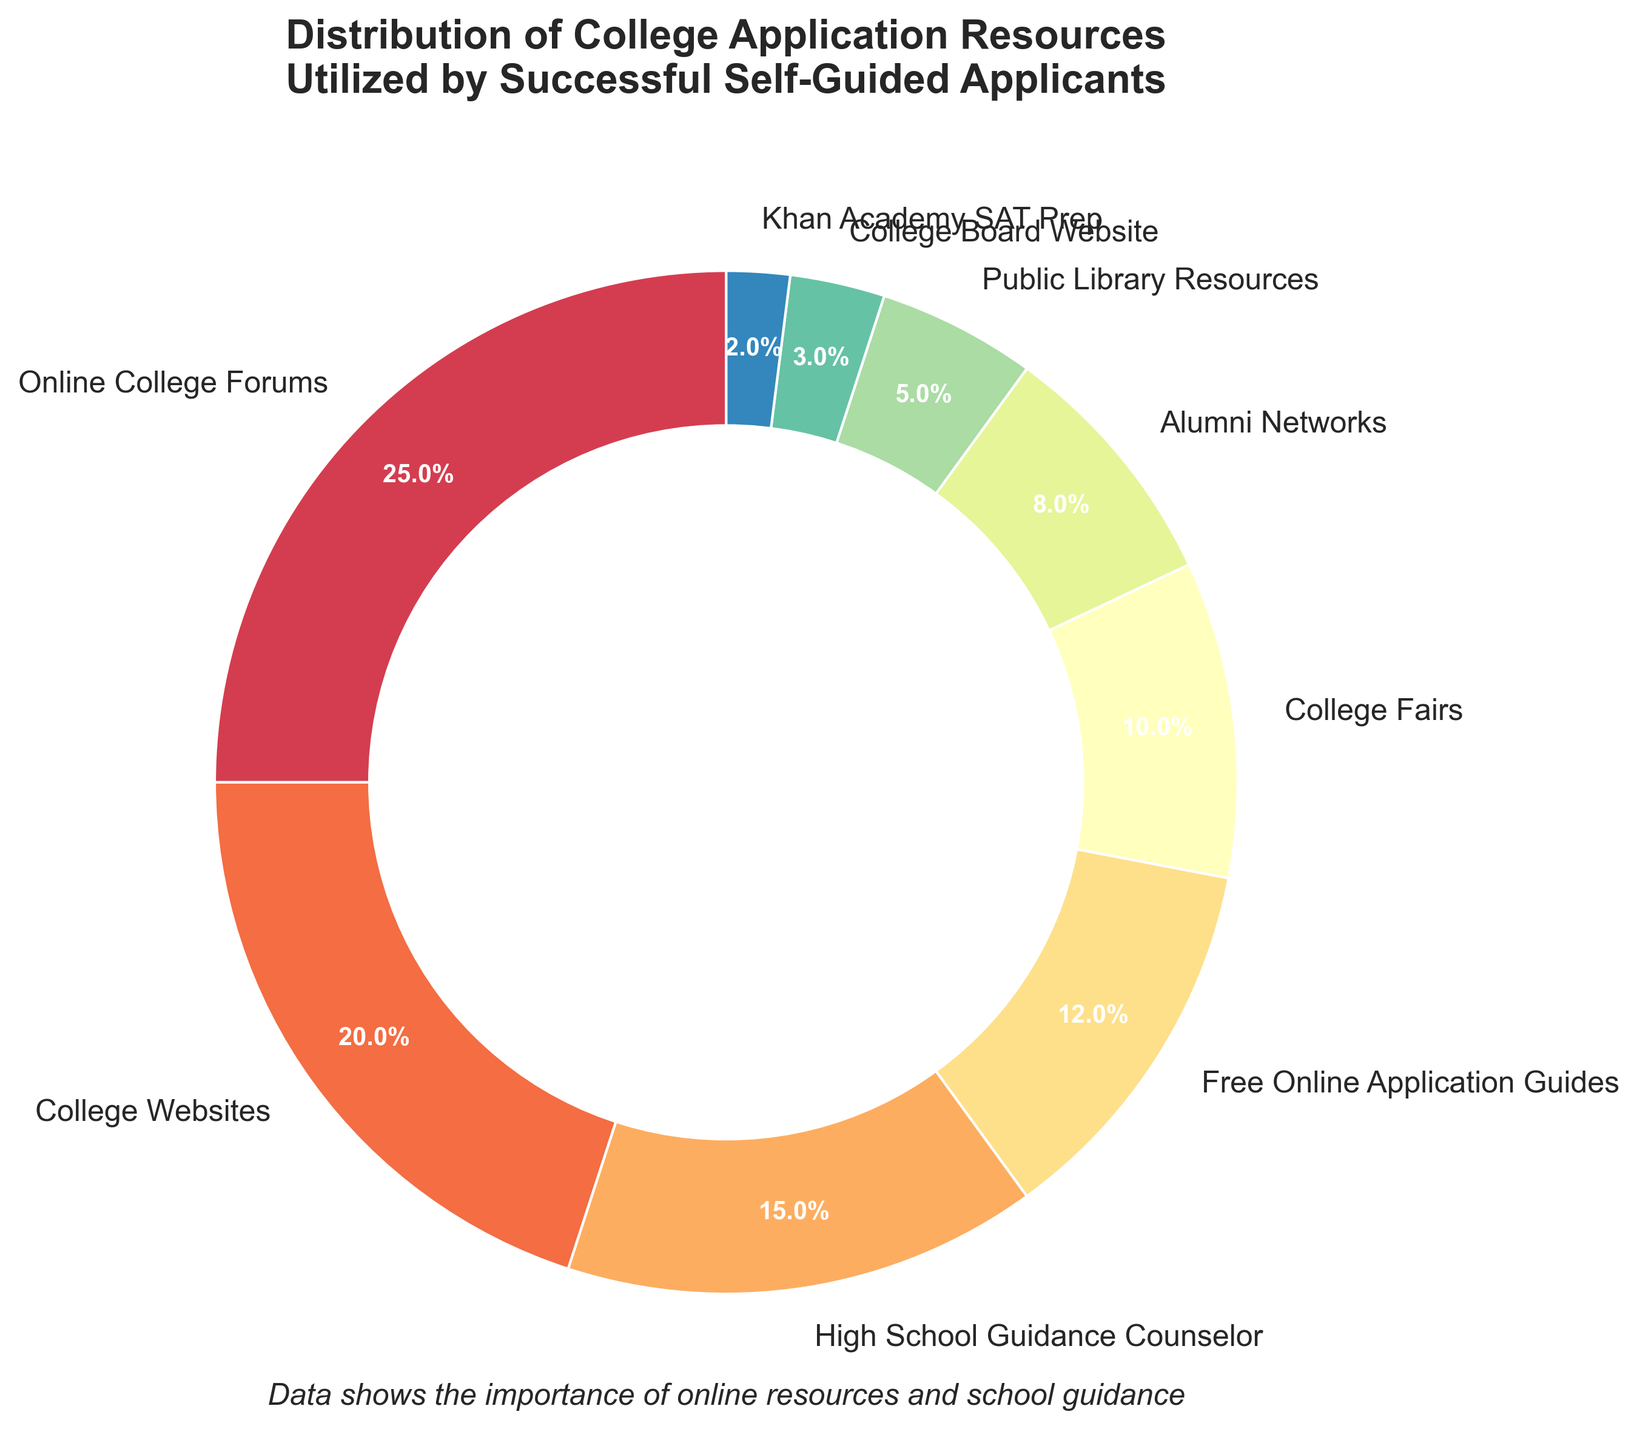What's the largest segment in the pie chart? The largest segment can be identified by looking at the size of the wedge and the percentage label. In this case, "Online College Forums" has the largest wedge with 25%.
Answer: Online College Forums Which two resources together account for more than 40%? Adding the percentages of the top resources will help determine which pair exceeds 40%. "Online College Forums" (25%) and "College Websites" (20%) together make up 45%.
Answer: Online College Forums and College Websites Is the percentage of users utilizing "High School Guidance Counselor" higher than those using "College Fairs"? Compare the slices for "High School Guidance Counselor" (15%) and "College Fairs" (10%). The percentage for the former is indeed higher.
Answer: Yes What is the percentage difference between “Free Online Application Guides” and “College Board Website”? Subtract the percentage of "College Board Website" (3%) from that of "Free Online Application Guides" (12%).
Answer: 9% What percentage of resources are accounted for by "Alumni Networks" and "Public Library Resources" together? Adding the percentages of "Alumni Networks" (8%) and "Public Library Resources" (5%) sums up their total contribution.
Answer: 13% Rank the top three resources based on usage percentage. By examining the percentages, we find that "Online College Forums" (25%), "College Websites" (20%), and "High School Guidance Counselor" (15%) are the top three.
Answer: Online College Forums, College Websites, High School Guidance Counselor Identify the resource with the lowest utilization and state its percentage. The smallest wedge and percentage label will indicate the least utilized resource, which is "Khan Academy SAT Prep" with 2%.
Answer: Khan Academy SAT Prep, 2% How do the combined percentages of "College Fairs" and "Public Library Resources" compare to that of "High School Guidance Counselor"? Summing "College Fairs" (10%) and "Public Library Resources" (5%) results in 15%, which is equal to the "High School Guidance Counselor" percentage.
Answer: Equal Which slice appears yellow and what percentage does it represent? The yellow slice represents "Free Online Application Guides" and is labeled with 12%.
Answer: Free Online Application Guides, 12% What fraction of the total resources does "Khan Academy SAT Prep" represent? With "Khan Academy SAT Prep" accounting for 2% of the total, its fraction of the 100% total can be expressed as 2/100 or 1/50.
Answer: 1/50 